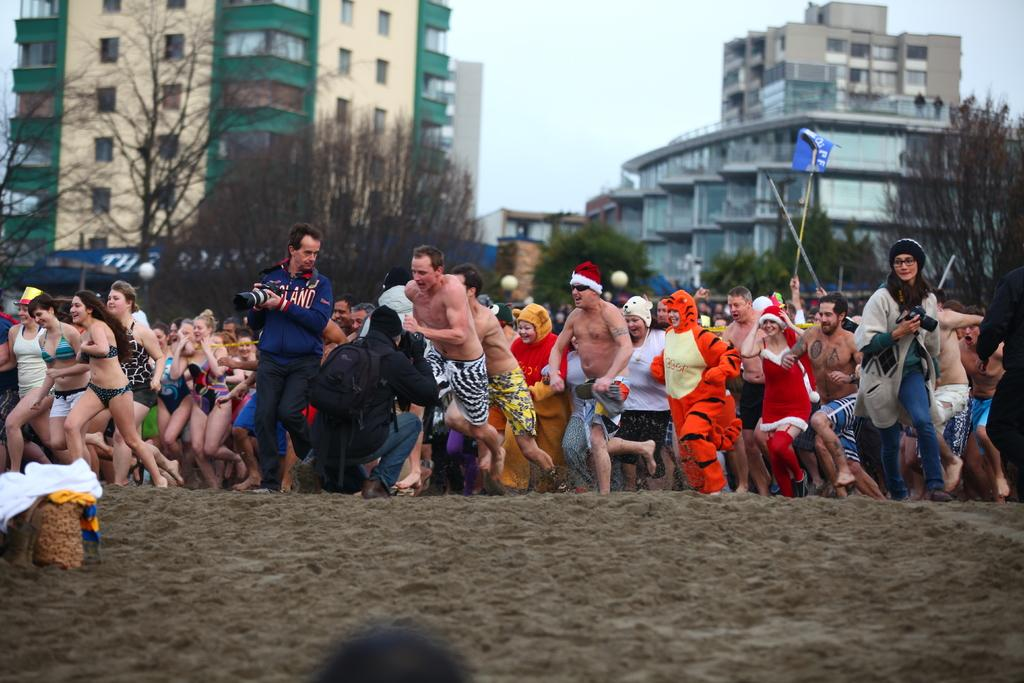How many people are in the image? There are many people in the image. What are the people doing in the image? The people are running. What type of natural elements can be seen in the image? There are trees in the image. What type of man-made structures can be seen in the image? There are buildings in the image. What is visible at the top of the image? The sky is visible at the top of the image. Can you see a stick being used to help the people run faster in the image? There is no stick present in the image, nor is there any indication that the people are using any tools to help them run faster. 